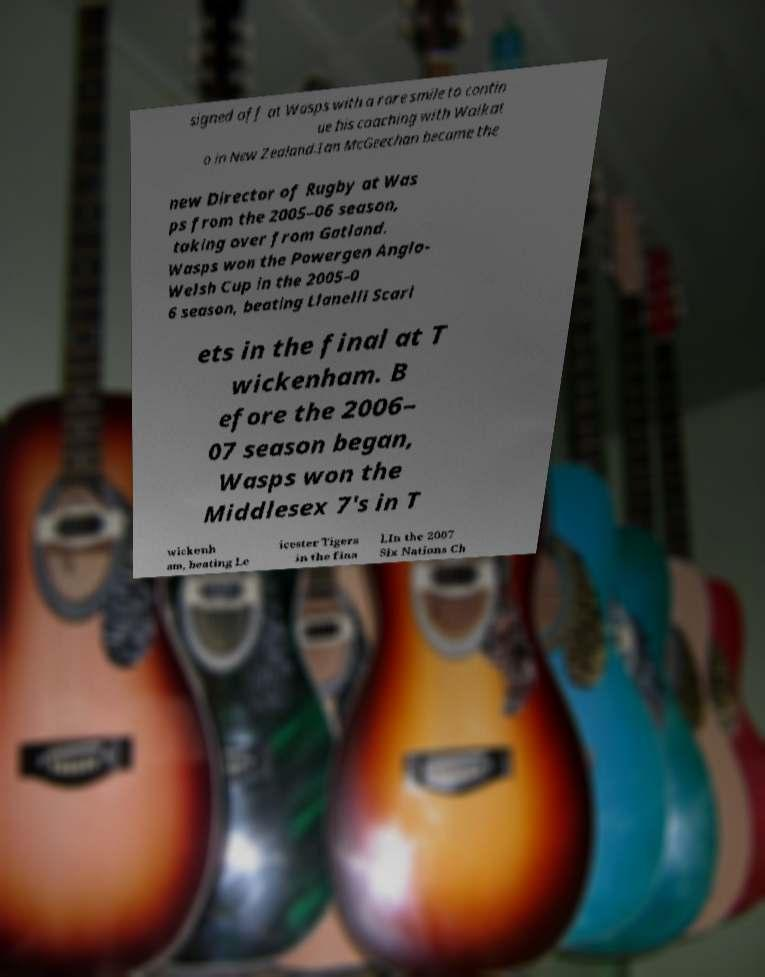There's text embedded in this image that I need extracted. Can you transcribe it verbatim? signed off at Wasps with a rare smile to contin ue his coaching with Waikat o in New Zealand.Ian McGeechan became the new Director of Rugby at Was ps from the 2005–06 season, taking over from Gatland. Wasps won the Powergen Anglo- Welsh Cup in the 2005–0 6 season, beating Llanelli Scarl ets in the final at T wickenham. B efore the 2006– 07 season began, Wasps won the Middlesex 7's in T wickenh am, beating Le icester Tigers in the fina l.In the 2007 Six Nations Ch 